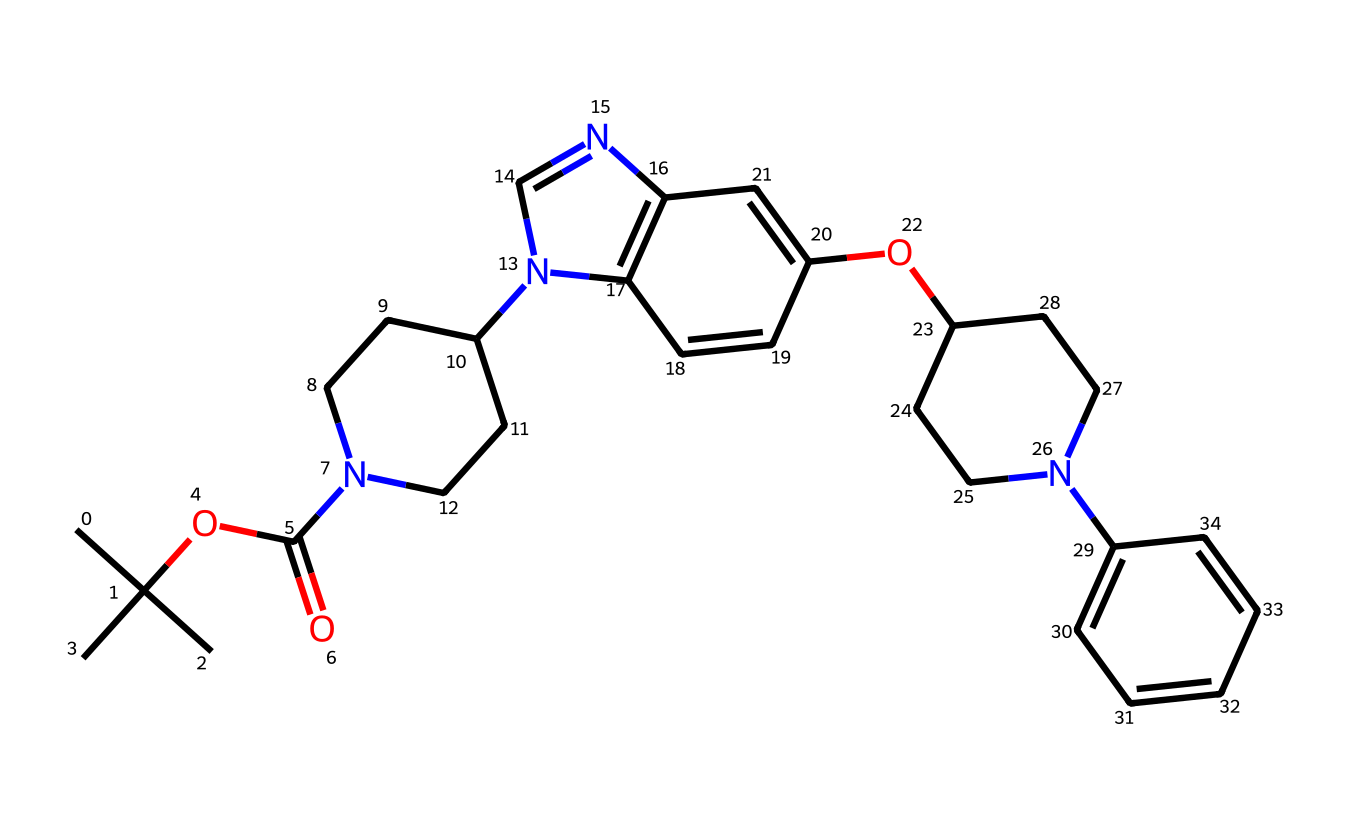What is the molecular formula of this compound? To determine the molecular formula, count the number of each type of atom present in the structure using the SMILES representation. This compound contains 19 carbon atoms, 24 hydrogen atoms, 4 nitrogen atoms, and 3 oxygen atoms, leading to the molecular formula C19H24N4O3.
Answer: C19H24N4O3 How many rings are present in the chemical structure? By examining the chemical structure, identify the cyclic parts. There appear to be three distinct rings in the structure, which can be counted by looking at how the atoms connect in the SMILES notation.
Answer: 3 What functional groups can be identified in this drug? The structure has multiple functional groups, including an ester (indicated by OC(=O)), amine (N), and multiple aromatic rings (the presence of alternating double bonds within rings). These functional groups are essential in determining the drug's properties.
Answer: ester, amine, aromatic Which atoms are the primary constituents of this compound? Review the molecular formula identified earlier. The primary constituents are carbon (C), hydrogen (H), nitrogen (N), and oxygen (O). These elements are central to the molecular structure and its biological activity.
Answer: carbon, hydrogen, nitrogen, oxygen What properties might this structure exhibit due to its amine groups? The presence of amine groups typically suggests basicity due to the lone pair of electrons on the nitrogen atoms, which can accept protons. This property may influence the drug’s interaction with biological targets.
Answer: basicity What type of drug action might this compound suggest based on its structure? Analyzing the structure and the presence of nitrogen-rich rings (typical in many pharmaceuticals and biologically active compounds) indicates it may exhibit properties related to enzyme inhibition or receptor modulation, common in drugs like steroids or cognitive enhancers.
Answer: enzyme inhibition, receptor modulation 